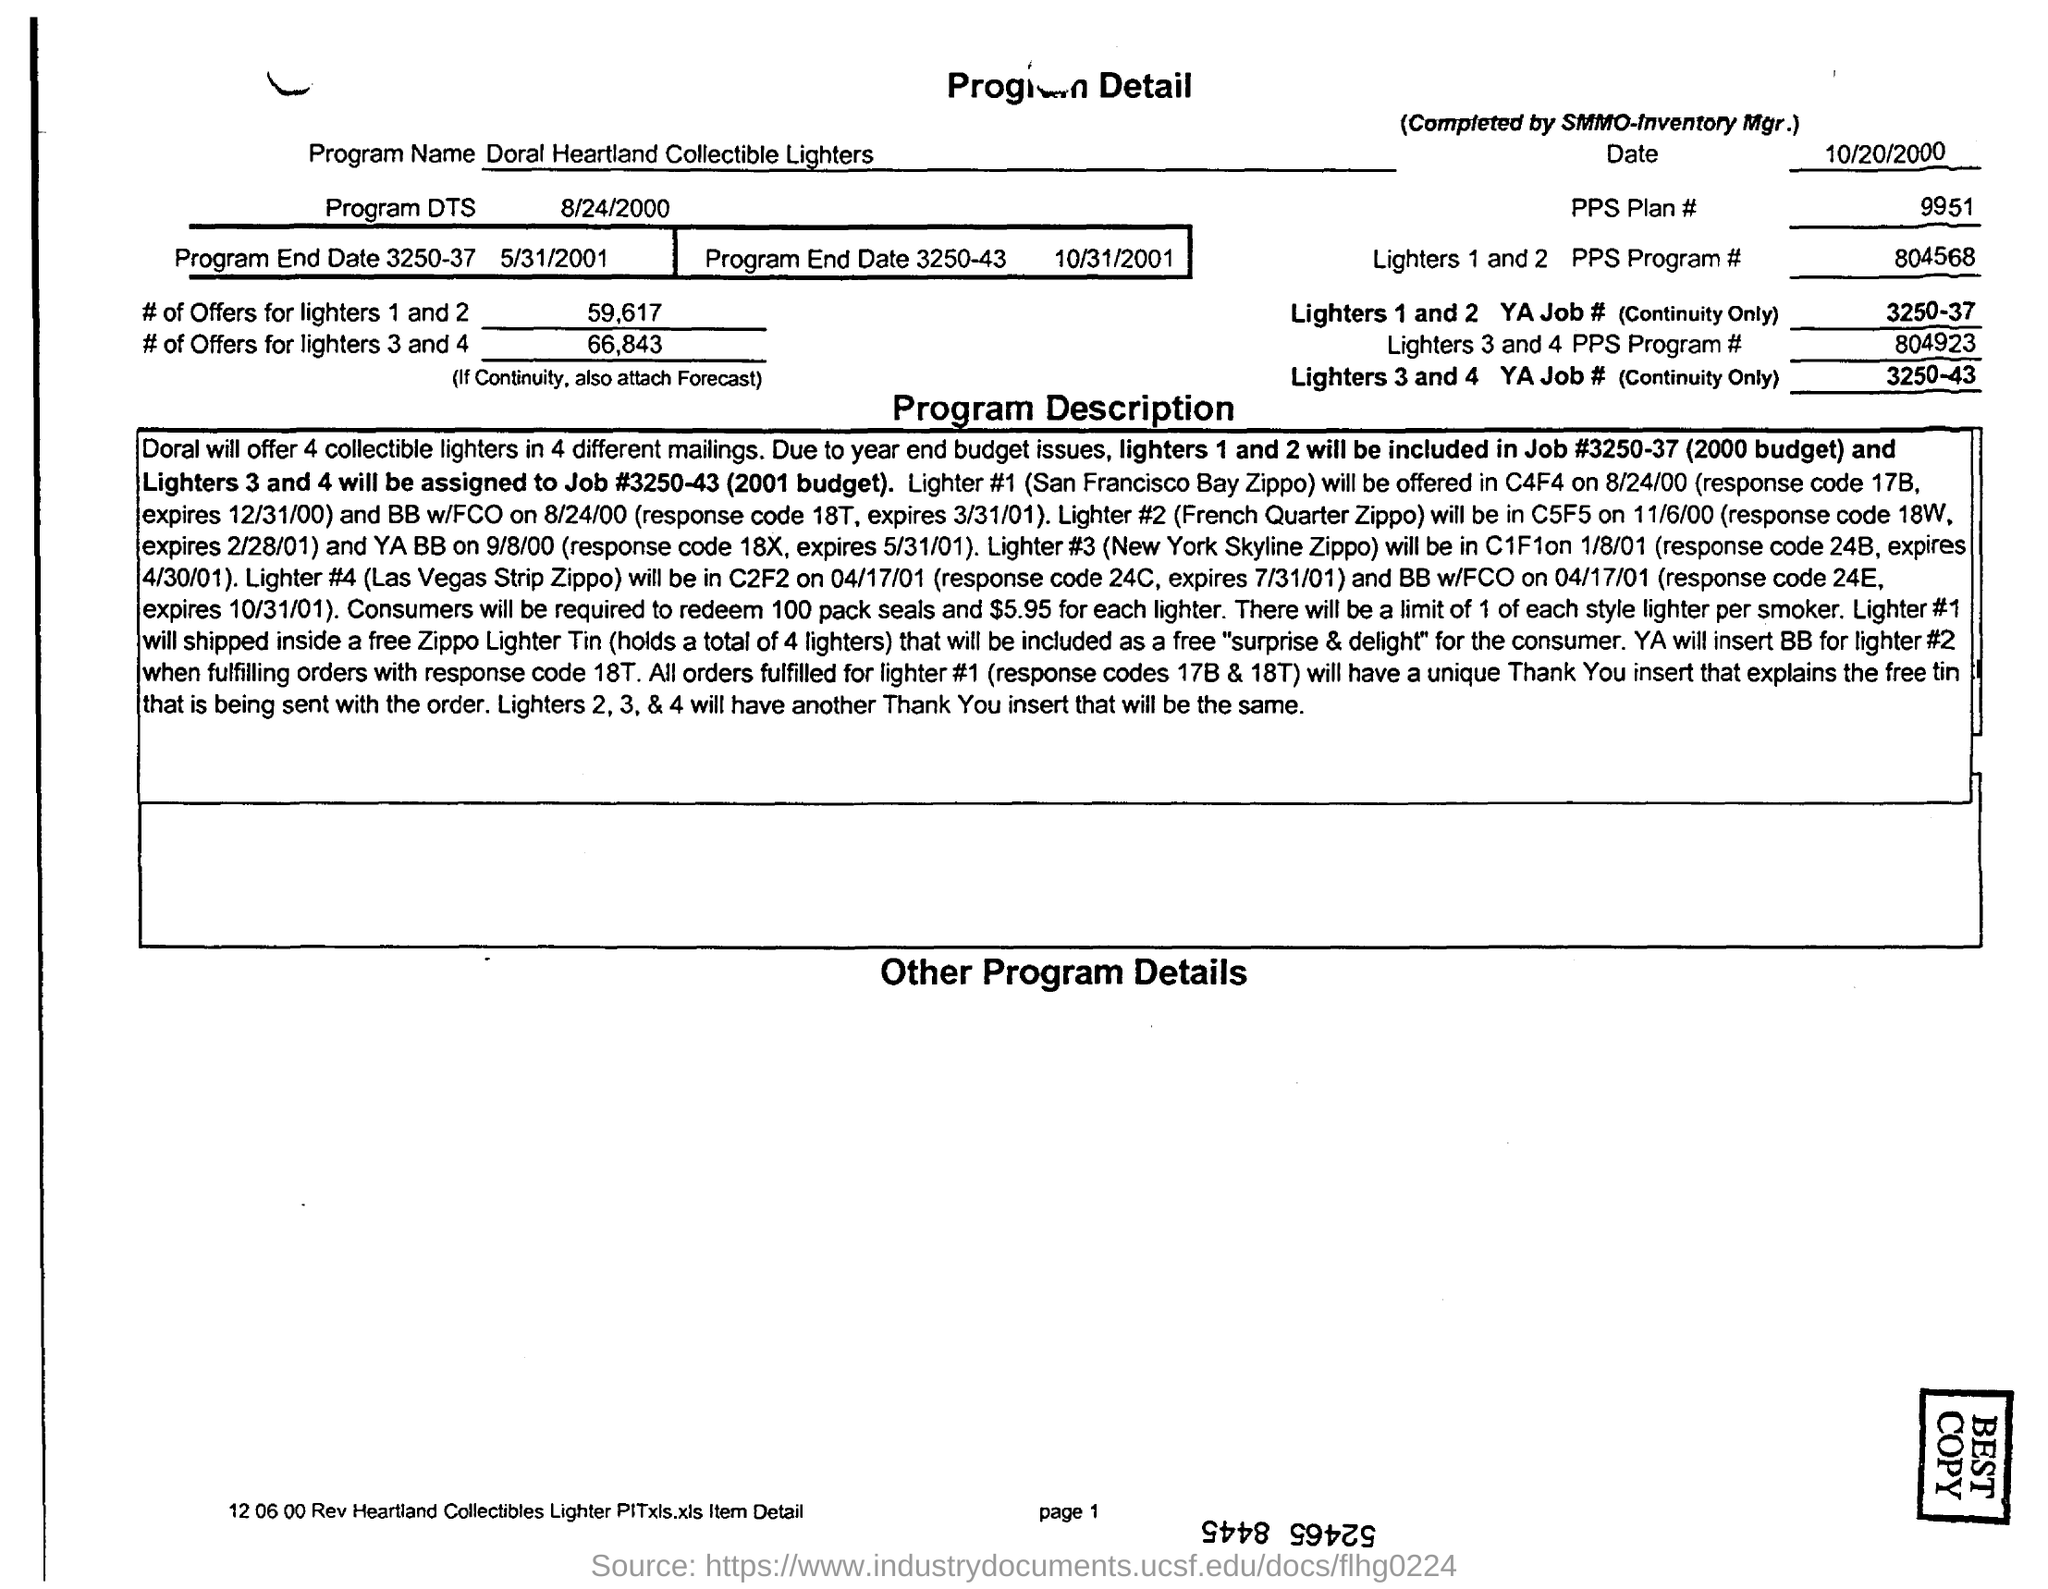Highlight a few significant elements in this photo. The product detail contains a program name, "Doral Heartland Collectible Lighters. The YA job number for Lighters 3 and 4 is 3250-43... The PPS program numbers for lighters 1 and 2 are 804568... The PPS program numbers for lighters 3 and 4 are 804923 and... The program 'dts' is mentioned in the program detail with a start date of 8/24/2000. 